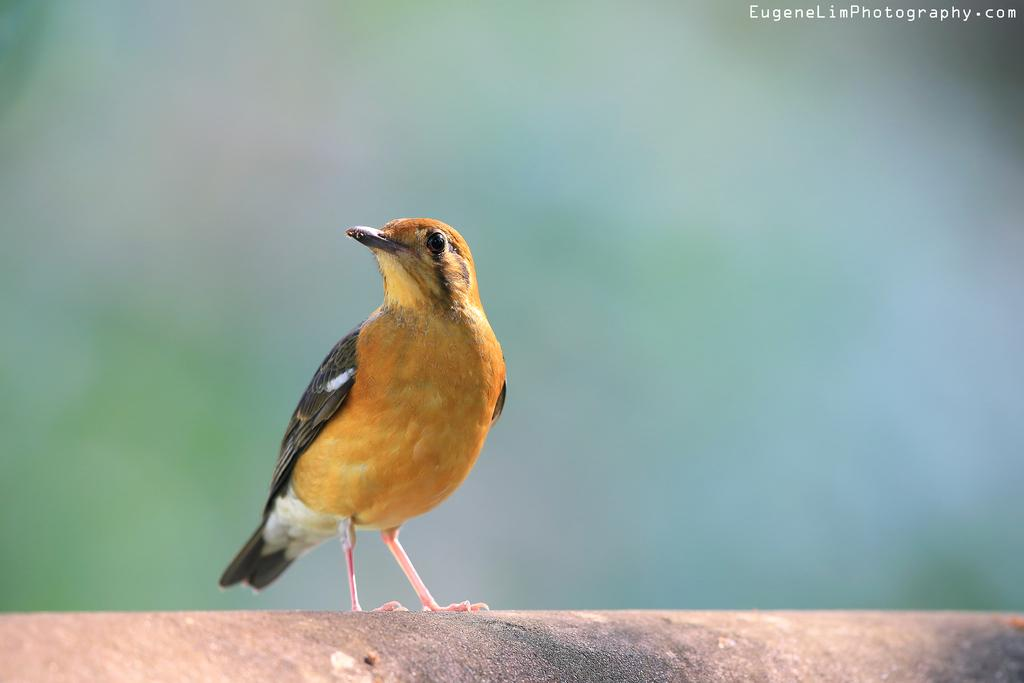What type of animal is in the image? There is a bird in the image. Where is the bird located? The bird is on a path. What can be observed about the background of the image? The background of the image is blurred. Is there any additional information or branding on the image? Yes, there is a watermark on the image. What impulse does the bird have to fly away in the image? The image does not provide information about the bird's impulses or emotions, so we cannot determine if it has an impulse to fly away. 